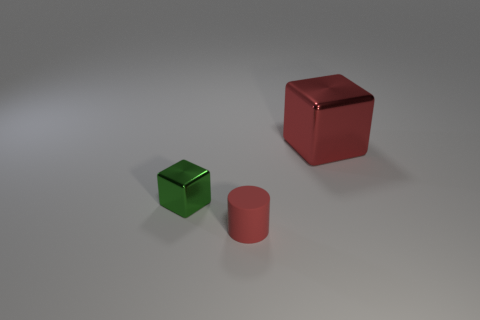What is the shape of the red rubber thing?
Make the answer very short. Cylinder. How many big metal objects are the same color as the small rubber thing?
Give a very brief answer. 1. There is another small thing that is the same shape as the red metallic thing; what color is it?
Provide a short and direct response. Green. There is a cube that is right of the red cylinder; what number of green metal things are in front of it?
Ensure brevity in your answer.  1. What number of spheres are red matte objects or small green metal objects?
Your response must be concise. 0. Are any metallic objects visible?
Keep it short and to the point. Yes. The other green metallic object that is the same shape as the large metallic object is what size?
Your answer should be very brief. Small. What is the shape of the small rubber object left of the metallic thing that is behind the small shiny object?
Your answer should be very brief. Cylinder. What number of purple things are tiny shiny blocks or small cylinders?
Offer a terse response. 0. What color is the tiny shiny cube?
Provide a short and direct response. Green. 